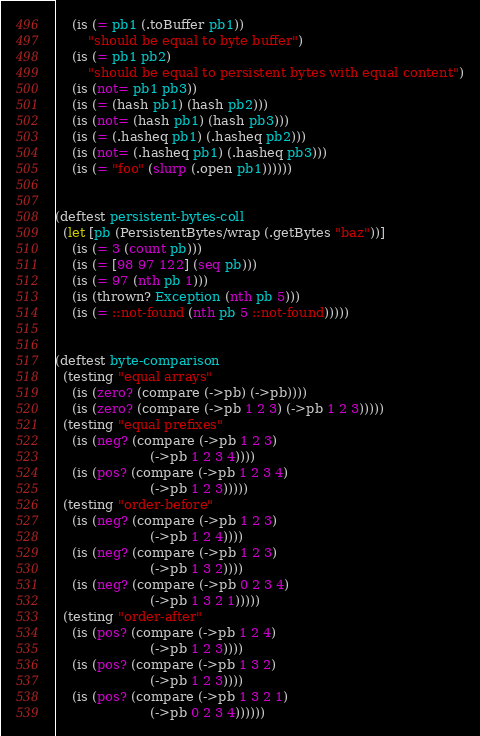<code> <loc_0><loc_0><loc_500><loc_500><_Clojure_>    (is (= pb1 (.toBuffer pb1))
        "should be equal to byte buffer")
    (is (= pb1 pb2)
        "should be equal to persistent bytes with equal content")
    (is (not= pb1 pb3))
    (is (= (hash pb1) (hash pb2)))
    (is (not= (hash pb1) (hash pb3)))
    (is (= (.hasheq pb1) (.hasheq pb2)))
    (is (not= (.hasheq pb1) (.hasheq pb3)))
    (is (= "foo" (slurp (.open pb1))))))


(deftest persistent-bytes-coll
  (let [pb (PersistentBytes/wrap (.getBytes "baz"))]
    (is (= 3 (count pb)))
    (is (= [98 97 122] (seq pb)))
    (is (= 97 (nth pb 1)))
    (is (thrown? Exception (nth pb 5)))
    (is (= ::not-found (nth pb 5 ::not-found)))))


(deftest byte-comparison
  (testing "equal arrays"
    (is (zero? (compare (->pb) (->pb))))
    (is (zero? (compare (->pb 1 2 3) (->pb 1 2 3)))))
  (testing "equal prefixes"
    (is (neg? (compare (->pb 1 2 3)
                       (->pb 1 2 3 4))))
    (is (pos? (compare (->pb 1 2 3 4)
                       (->pb 1 2 3)))))
  (testing "order-before"
    (is (neg? (compare (->pb 1 2 3)
                       (->pb 1 2 4))))
    (is (neg? (compare (->pb 1 2 3)
                       (->pb 1 3 2))))
    (is (neg? (compare (->pb 0 2 3 4)
                       (->pb 1 3 2 1)))))
  (testing "order-after"
    (is (pos? (compare (->pb 1 2 4)
                       (->pb 1 2 3))))
    (is (pos? (compare (->pb 1 3 2)
                       (->pb 1 2 3))))
    (is (pos? (compare (->pb 1 3 2 1)
                       (->pb 0 2 3 4))))))
</code> 